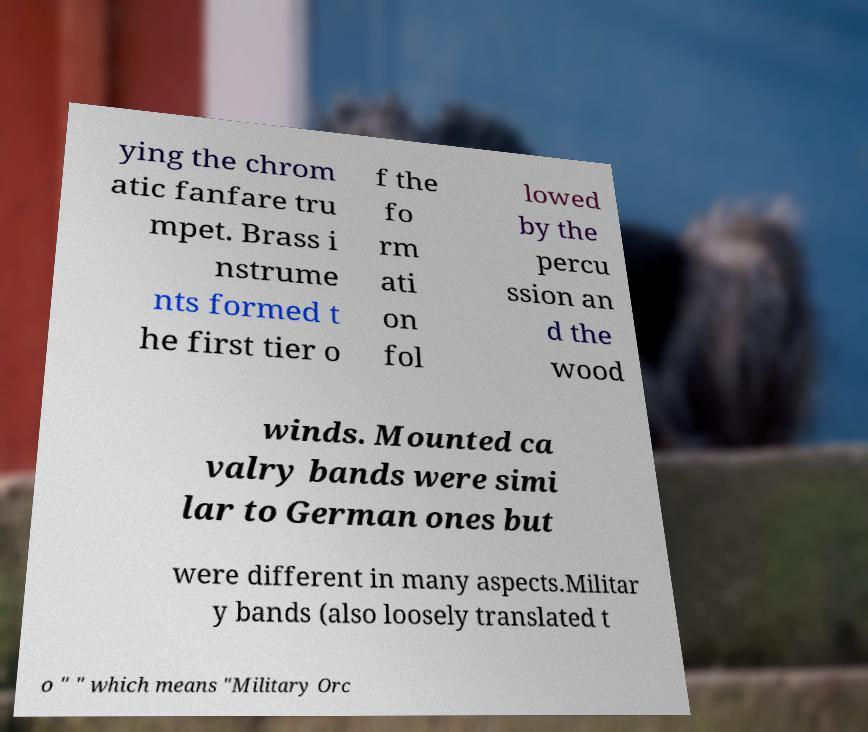For documentation purposes, I need the text within this image transcribed. Could you provide that? ying the chrom atic fanfare tru mpet. Brass i nstrume nts formed t he first tier o f the fo rm ati on fol lowed by the percu ssion an d the wood winds. Mounted ca valry bands were simi lar to German ones but were different in many aspects.Militar y bands (also loosely translated t o " " which means "Military Orc 